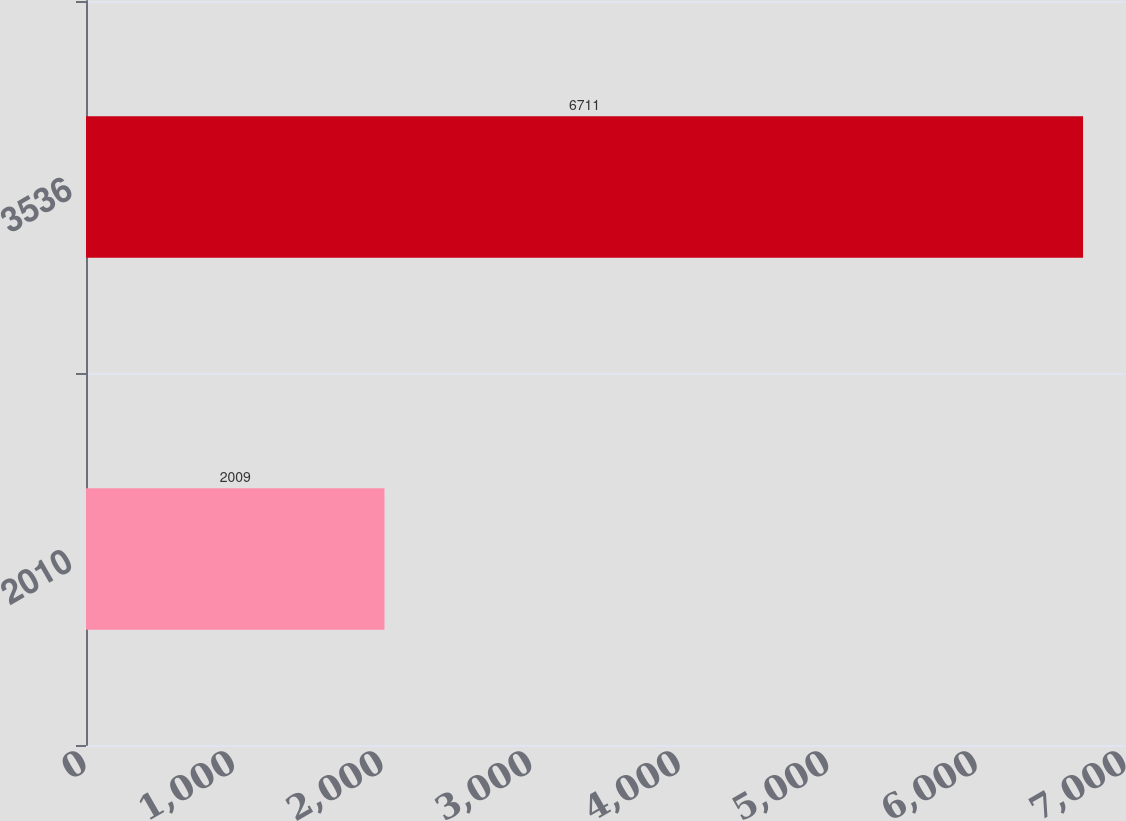Convert chart to OTSL. <chart><loc_0><loc_0><loc_500><loc_500><bar_chart><fcel>2010<fcel>3536<nl><fcel>2009<fcel>6711<nl></chart> 